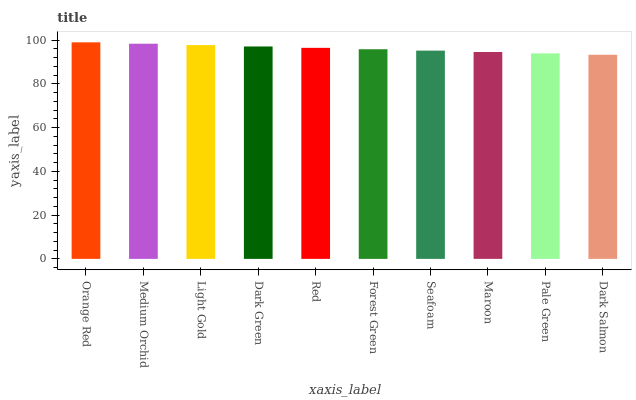Is Dark Salmon the minimum?
Answer yes or no. Yes. Is Orange Red the maximum?
Answer yes or no. Yes. Is Medium Orchid the minimum?
Answer yes or no. No. Is Medium Orchid the maximum?
Answer yes or no. No. Is Orange Red greater than Medium Orchid?
Answer yes or no. Yes. Is Medium Orchid less than Orange Red?
Answer yes or no. Yes. Is Medium Orchid greater than Orange Red?
Answer yes or no. No. Is Orange Red less than Medium Orchid?
Answer yes or no. No. Is Red the high median?
Answer yes or no. Yes. Is Forest Green the low median?
Answer yes or no. Yes. Is Orange Red the high median?
Answer yes or no. No. Is Dark Salmon the low median?
Answer yes or no. No. 